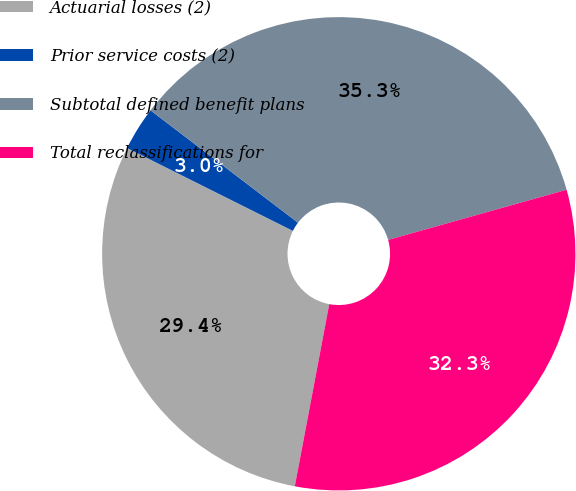Convert chart to OTSL. <chart><loc_0><loc_0><loc_500><loc_500><pie_chart><fcel>Actuarial losses (2)<fcel>Prior service costs (2)<fcel>Subtotal defined benefit plans<fcel>Total reclassifications for<nl><fcel>29.4%<fcel>2.99%<fcel>35.28%<fcel>32.34%<nl></chart> 